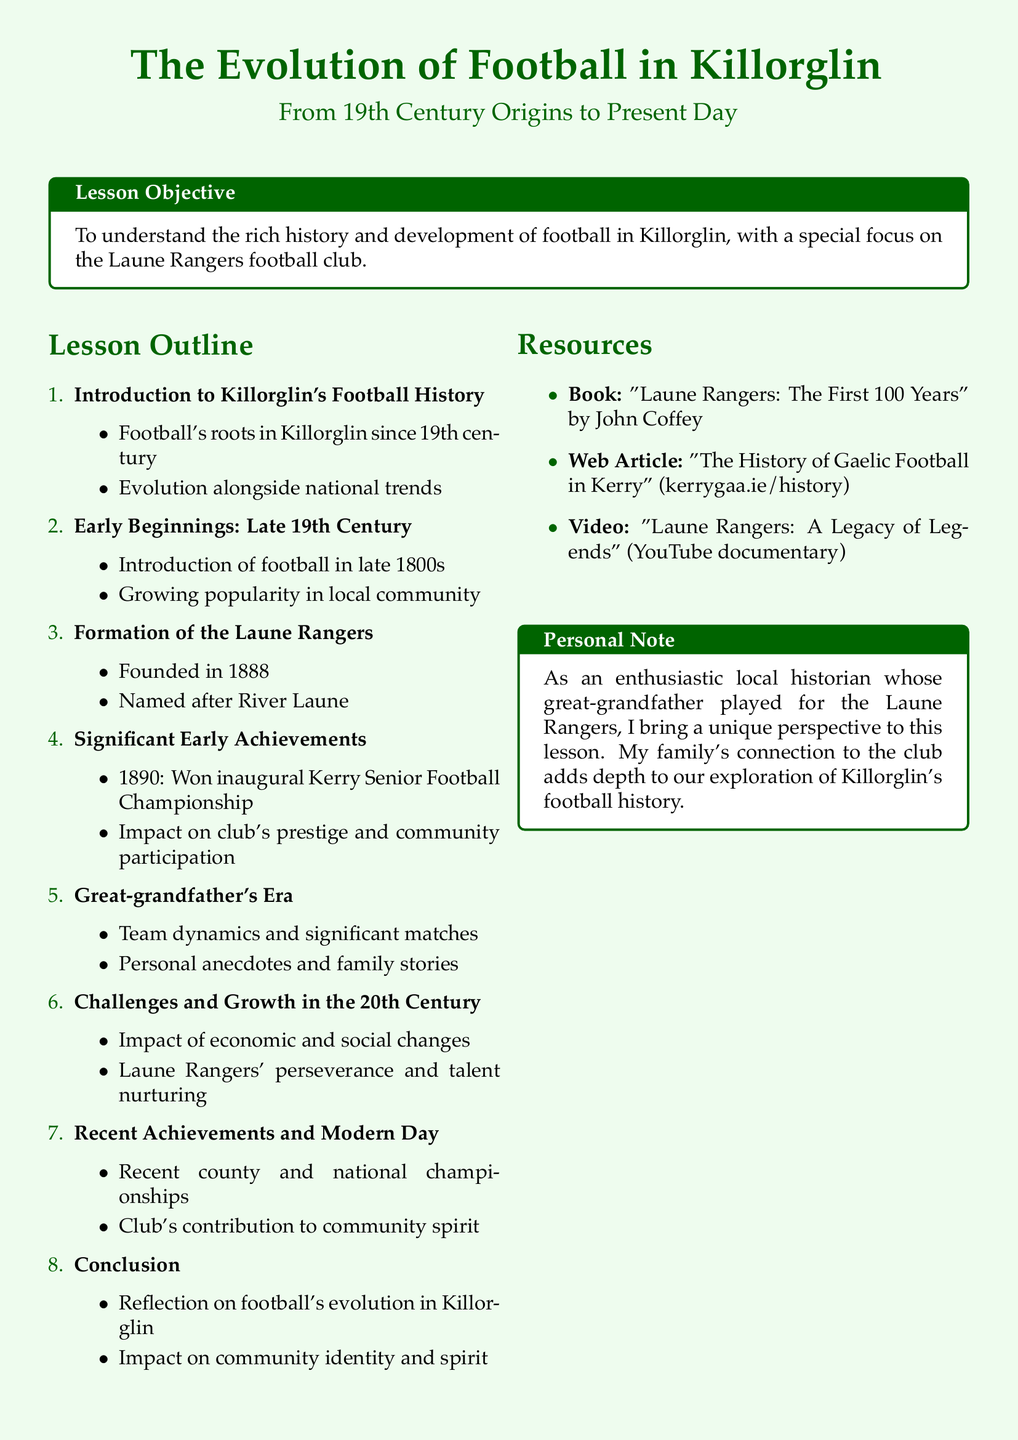What year was the Laune Rangers founded? The document states that Laune Rangers was founded in 1888.
Answer: 1888 What championship did the Laune Rangers win in 1890? The document mentions that they won the inaugural Kerry Senior Football Championship in 1890.
Answer: Kerry Senior Football Championship What significant impact did the 1890 victory have? The document describes the impact as increasing the club's prestige and community participation.
Answer: Prestige and community participation What does the lesson objective focus on? The document outlines that the lesson objective is to understand the rich history and development of football in Killorglin.
Answer: Rich history and development What perspective does the author bring to the lesson? The personal note indicates that the author brings a unique perspective as someone with a family connection to the Laune Rangers.
Answer: Unique perspective What major changes affected football in the 20th century? The document highlights that economic and social changes impacted football during this period.
Answer: Economic and social changes What type of resources are included in the lesson? The document lists books, web articles, and videos as resources.
Answer: Books, web articles, and videos What does the conclusion reflect on? The document mentions that the conclusion reflects on football's evolution in Killorglin.
Answer: Football's evolution in Killorglin 